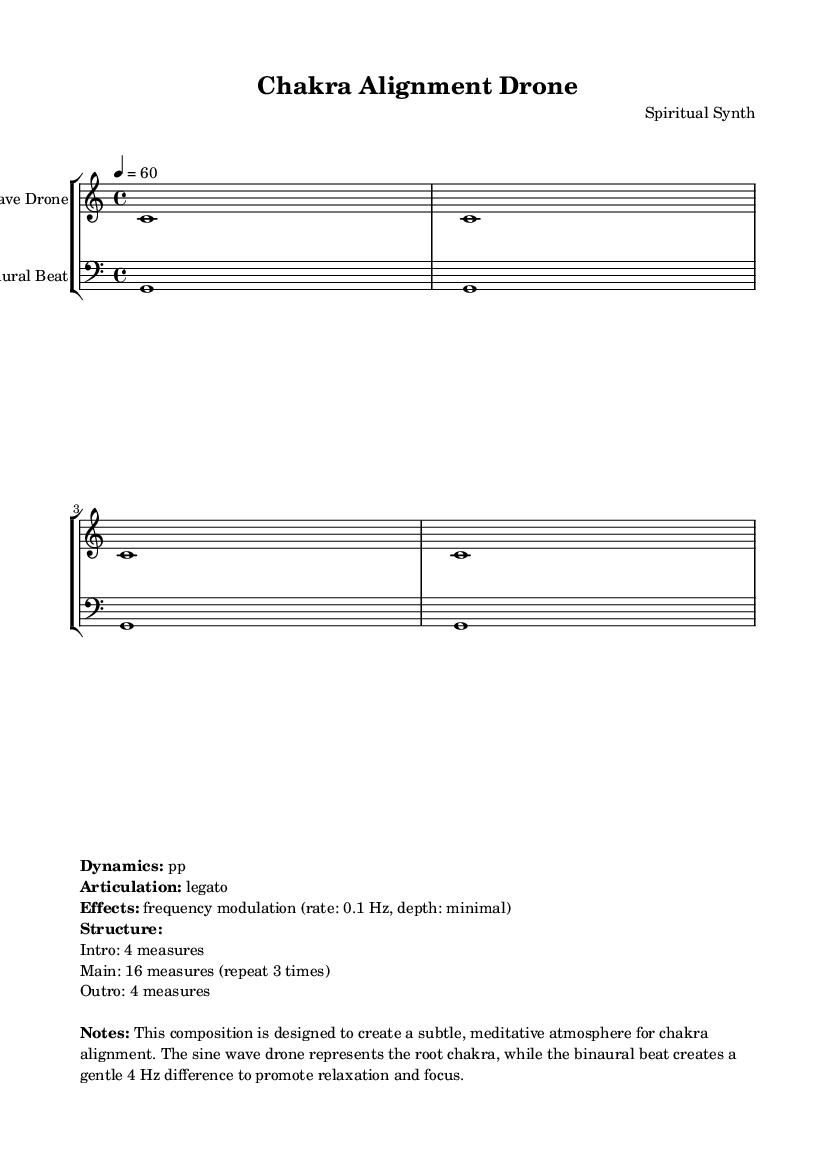What is the key signature of this music? The key signature is C major, which has no sharps or flats indicated in the sheet music header.
Answer: C major What is the time signature of this music? The time signature is indicated in the global section of the sheet music as 4/4, meaning there are four beats in each measure.
Answer: 4/4 What is the tempo marking given in the score? The tempo marking is specified as 4 = 60, meaning there are 60 beats per minute. This indicates a moderate pace for the piece.
Answer: 60 What is the instrument used for the drone? The instrument specified for the drone is named "Sine Wave Drone" in the staff part of the music.
Answer: Sine Wave Drone How many measures are in the main section of the piece? The main section is indicated in the markup notes to consist of 16 measures, and it is directed to repeat 3 times.
Answer: 16 measures What frequency difference is created by the binaural beat? The binaural beat's frequency modulation is detailed as a gentle 4 Hz difference, which is designed to promote relaxation and focus.
Answer: 4 Hz Describe the dynamics of the piece. The dynamics are marked as pp, indicating a very soft volume throughout the performance of this piece.
Answer: pp 